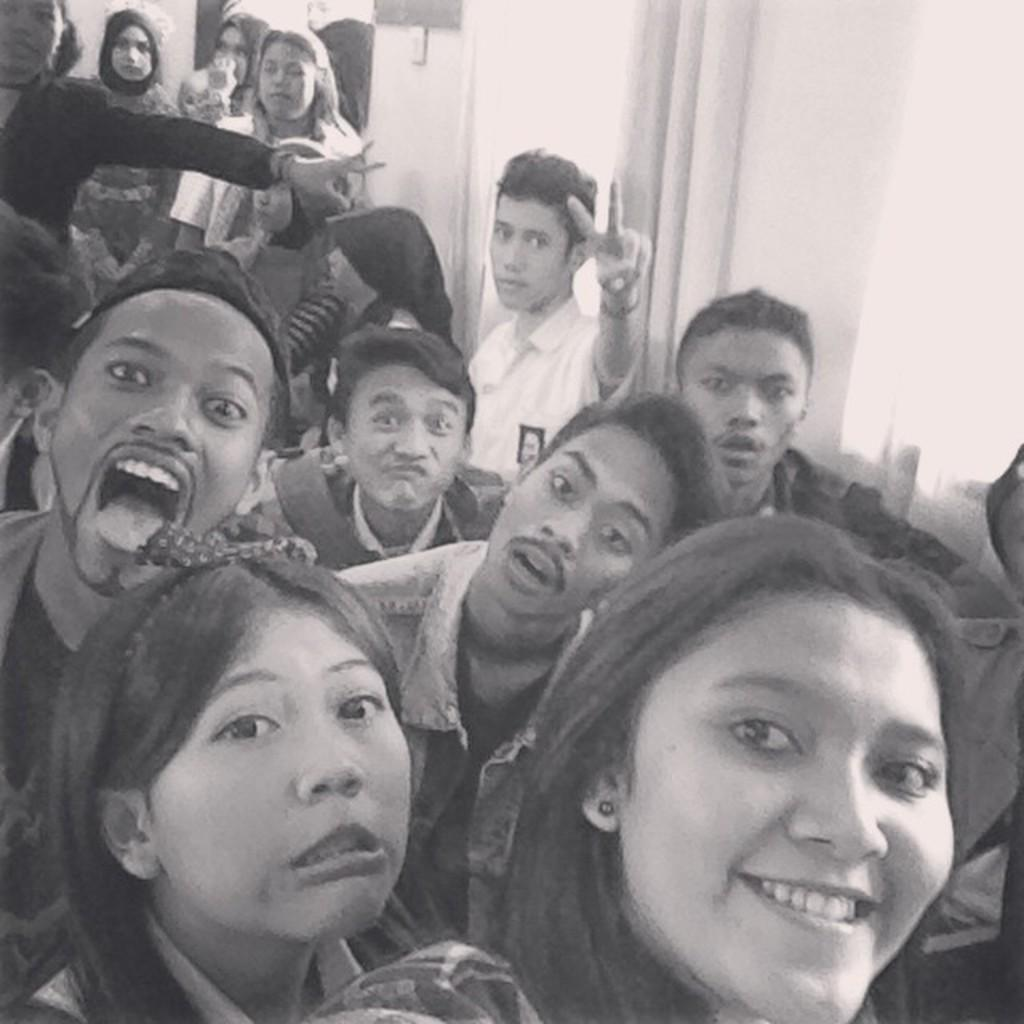What is the color scheme of the image? The image is black and white. Can you describe the subjects in the image? There are a few people visible in the image. What type of corn can be seen growing in the image? There is no corn present in the image; it is a black and white image with a few people visible. What button can be pushed to change the color of the image? The image is not a digital image, and there is no button to change its color. 